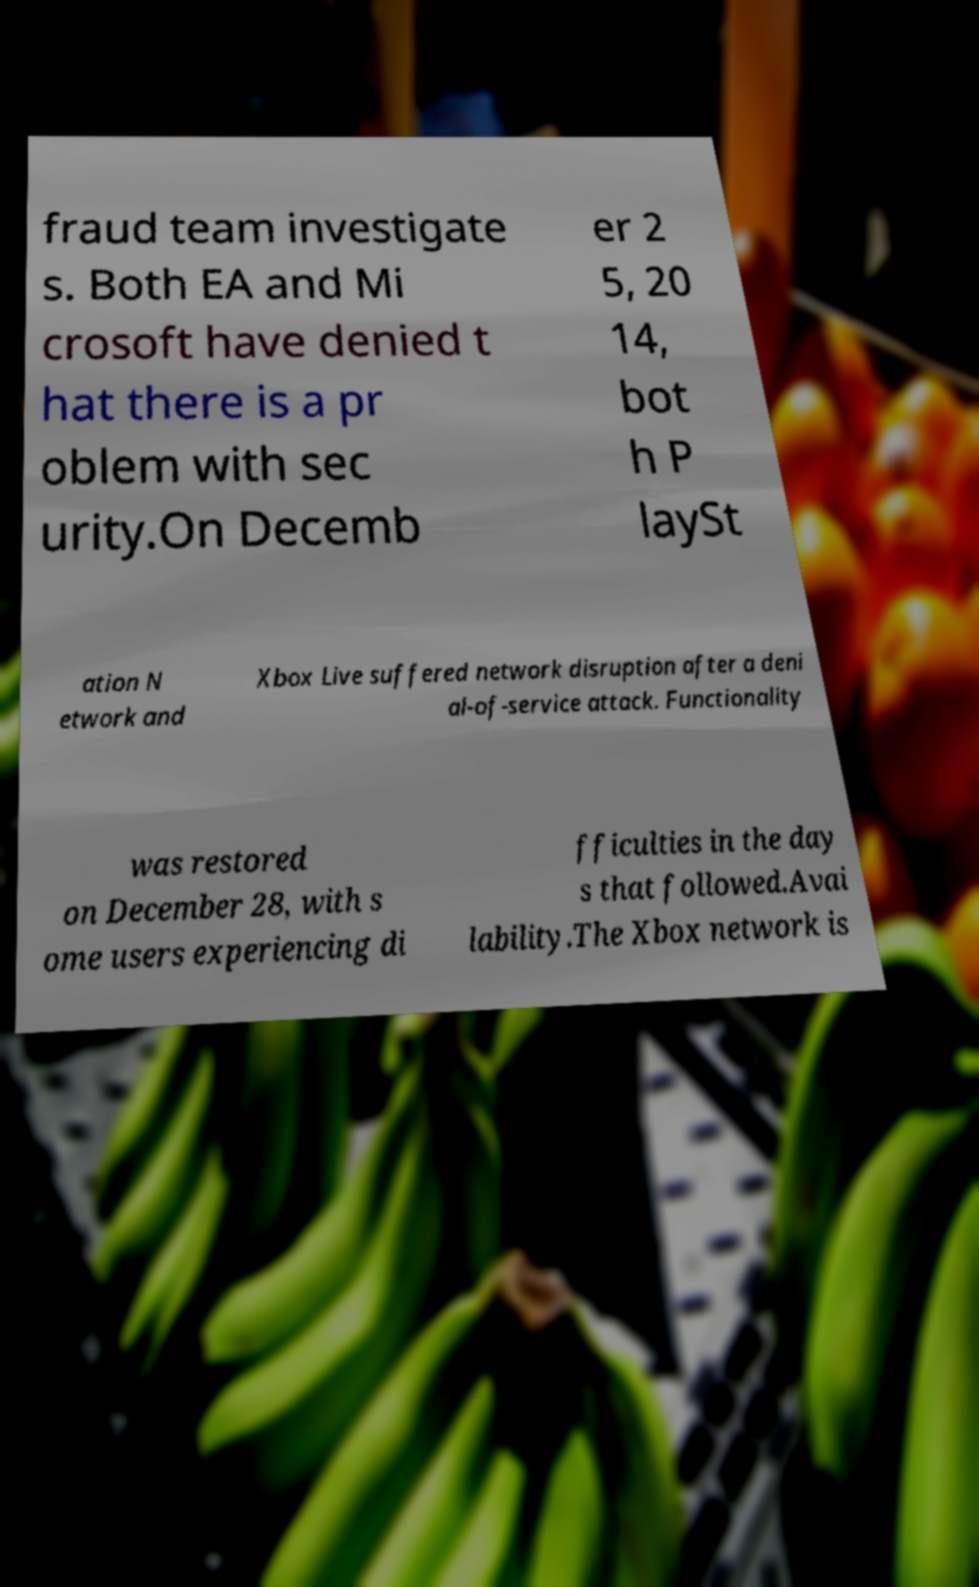Please identify and transcribe the text found in this image. fraud team investigate s. Both EA and Mi crosoft have denied t hat there is a pr oblem with sec urity.On Decemb er 2 5, 20 14, bot h P laySt ation N etwork and Xbox Live suffered network disruption after a deni al-of-service attack. Functionality was restored on December 28, with s ome users experiencing di fficulties in the day s that followed.Avai lability.The Xbox network is 